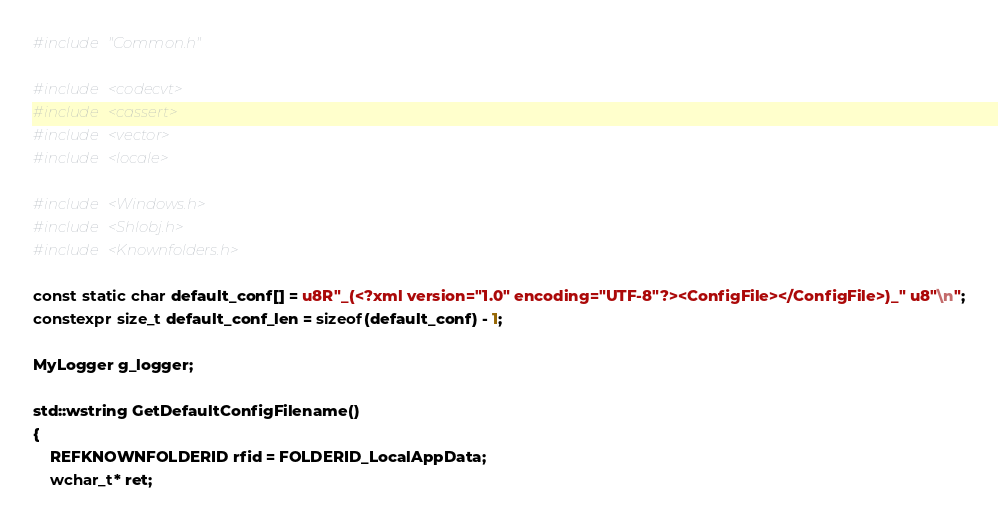Convert code to text. <code><loc_0><loc_0><loc_500><loc_500><_C++_>#include "Common.h"

#include <codecvt>
#include <cassert>
#include <vector>
#include <locale>

#include <Windows.h>
#include <Shlobj.h>
#include <Knownfolders.h>

const static char default_conf[] = u8R"_(<?xml version="1.0" encoding="UTF-8"?><ConfigFile></ConfigFile>)_" u8"\n";
constexpr size_t default_conf_len = sizeof(default_conf) - 1;

MyLogger g_logger;

std::wstring GetDefaultConfigFilename()
{
	REFKNOWNFOLDERID rfid = FOLDERID_LocalAppData;
	wchar_t* ret;</code> 